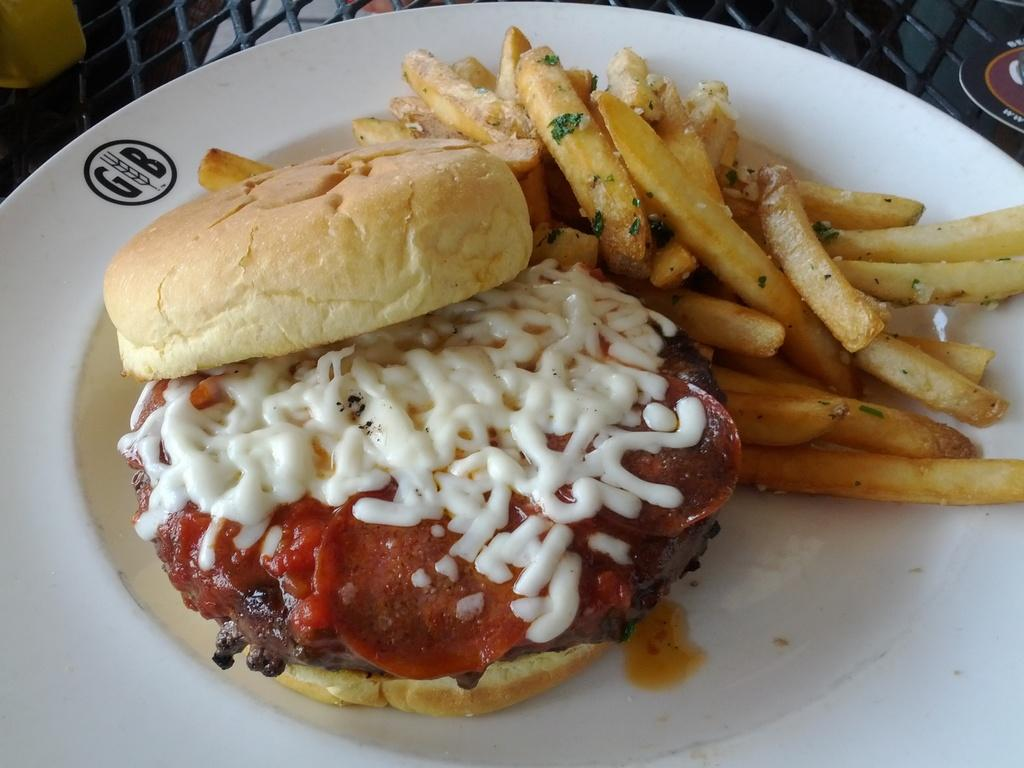What is on the plate that is visible in the image? The plate contains a burger and french fries. Where is the plate located in the image? The plate is present on a table. What type of furniture is present in the image? There is no furniture mentioned or visible in the image; only a plate with a burger and french fries on a table is present. 